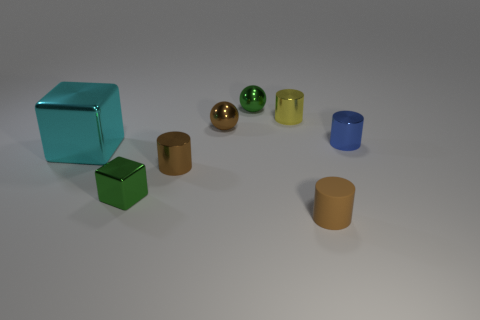Subtract all green cylinders. Subtract all yellow blocks. How many cylinders are left? 4 Add 1 brown objects. How many objects exist? 9 Subtract all cubes. How many objects are left? 6 Subtract 0 gray spheres. How many objects are left? 8 Subtract all gray rubber cylinders. Subtract all green cubes. How many objects are left? 7 Add 8 small blocks. How many small blocks are left? 9 Add 8 green metal blocks. How many green metal blocks exist? 9 